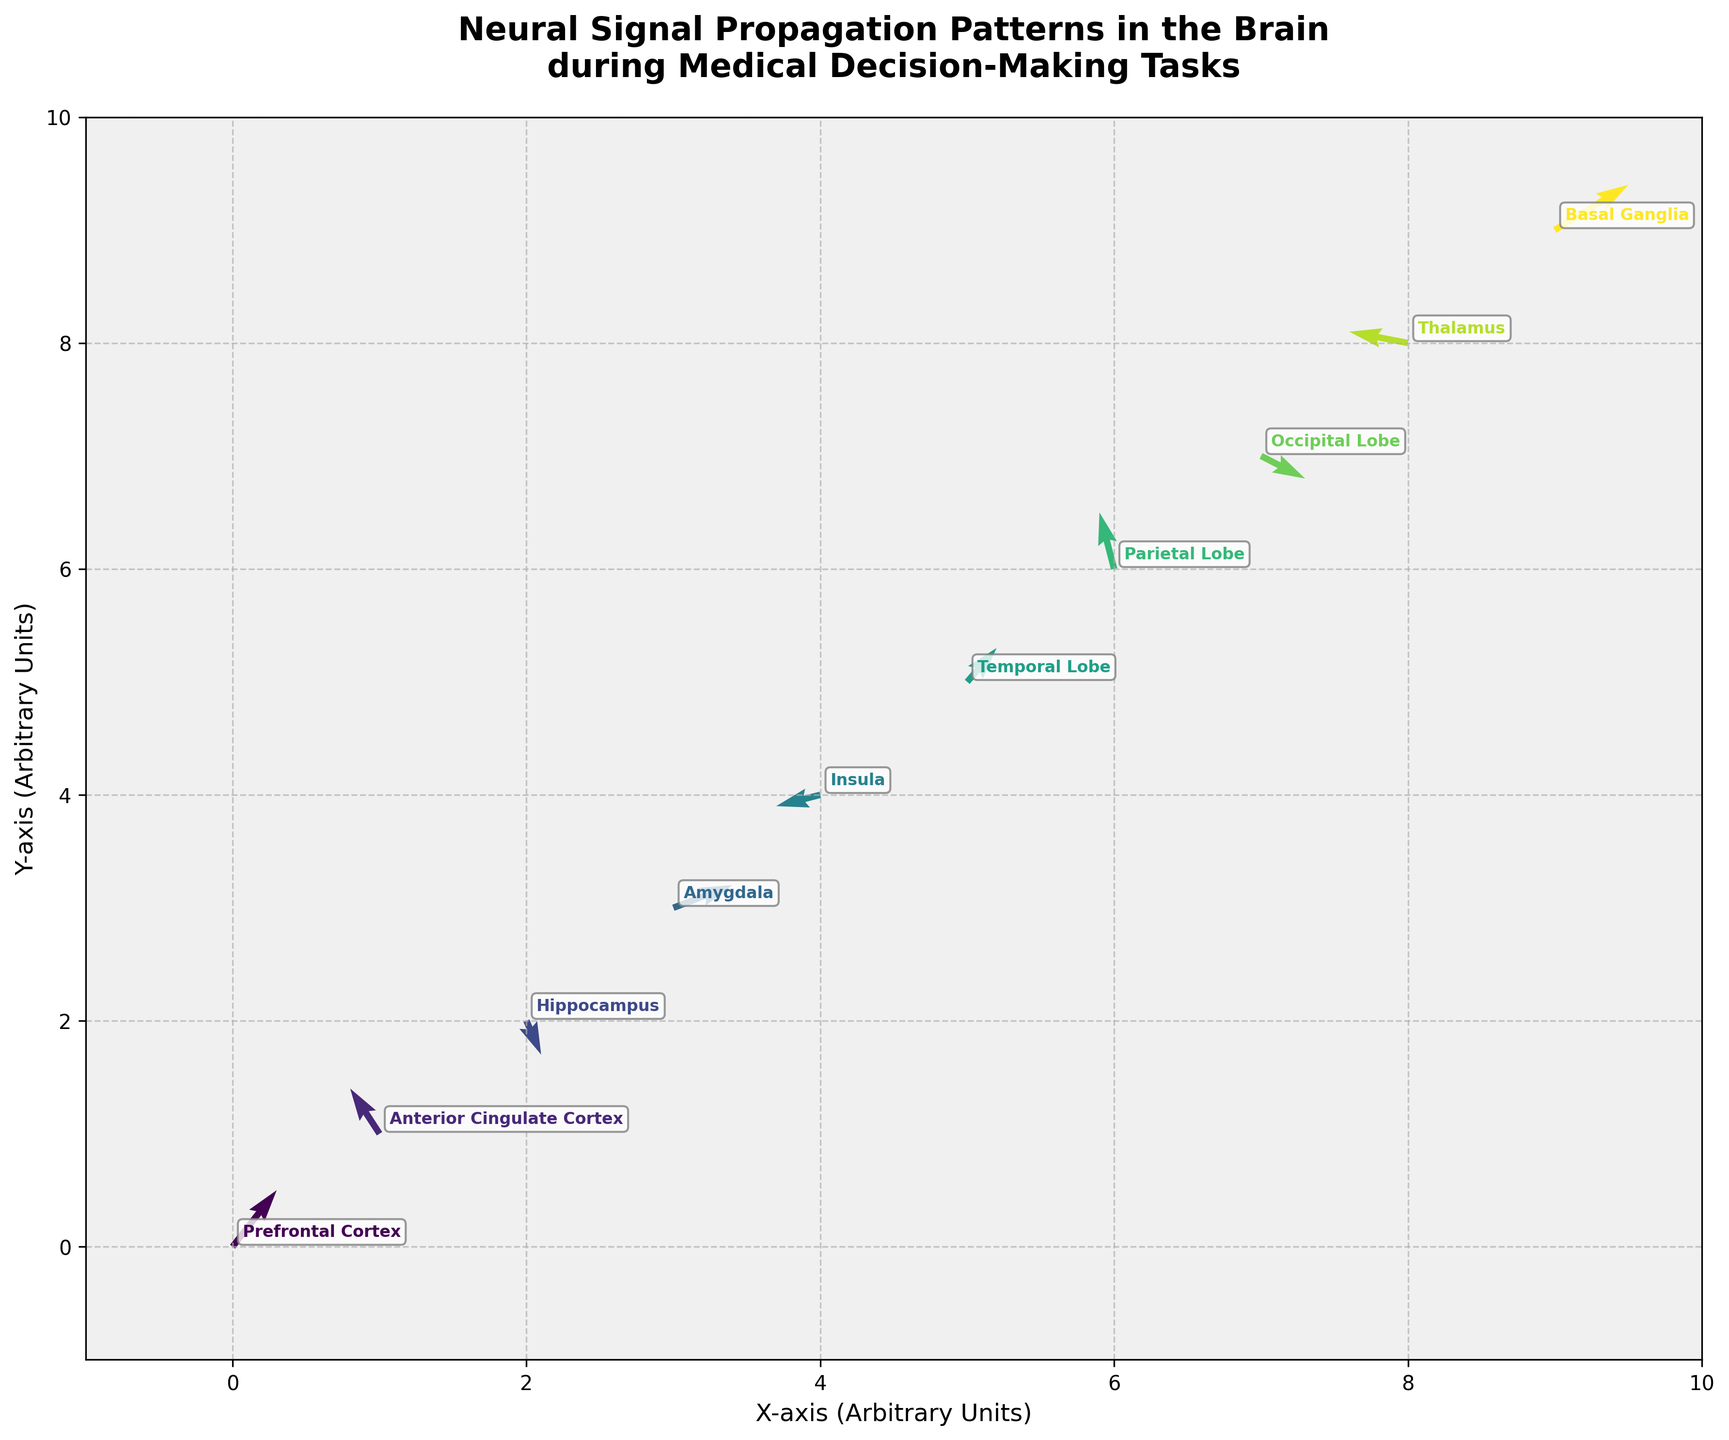What is the title of the figure? The title of the figure is provided near the top of the plot, usually in larger and bold font. It reads 'Neural Signal Propagation Patterns in the Brain during Medical Decision-Making Tasks'.
Answer: Neural Signal Propagation Patterns in the Brain during Medical Decision-Making Tasks How many regions are labeled in the plot? The plot has labels for each of the regions where neural signals are being measured. By counting each label, we find that there are 10 regions labeled.
Answer: 10 Which region shows the largest horizontal (x-axis) signal propagation? To determine this, we look at the magnitude of the horizontal (x-axis) component of the vectors, denoted as \(u\). The Basal Ganglia has the highest u value of 0.5, which is the largest horizontal signal propagation.
Answer: Basal Ganglia Which two regions have opposite directions in signal propagation in the vertical (y-axis) direction? We compare the vertical components (v) of the vectors. The Prefrontal Cortex has a v value of 0.5, indicating upward direction, while the Hippocampus has a v value of -0.3, indicating downward direction. Hence, these two regions have opposite directions in the vertical signal propagation.
Answer: Prefrontal Cortex and Hippocampus What are the coordinates for both the Parietal Lobe and Occipital Lobe in the plot? The coordinates are provided by the x and y columns for each region. Parietal Lobe is at (6, 6) and Occipital Lobe is at (7, 7) as shown on the plot.
Answer: (6, 6) and (7, 7) Which region has the second smallest horizontal (u) signal component? To find the second smallest horizontal component, we list out the u values and find the smallest and second smallest. The second smallest value is -0.3, which belongs to the Insula.
Answer: Insula What is the direction of the signal propagation in the Anterior Cingulate Cortex? By looking at the vector corresponding to the Anterior Cingulate Cortex, with u = -0.2 and v = 0.4, the signal propagation is in the direction of -0.2 units on the x-axis (leftward) and 0.4 units on the y-axis (upward).
Answer: Leftward and Upward What is the sum of the horizontal components of the signal propagation vectors for all regions? Summing the u values for all regions: 0.3 + (-0.2) + 0.1 + 0.4 + (-0.3) + 0.2 + (-0.1) + 0.3 + (-0.4) + 0.5 results in a total of 1.0.
Answer: 1.0 Which region has the vector with the smallest magnitude, and what is the value? The magnitude of vectors is calculated as √(u² + v²). By computing it for each, the smallest magnitude is found to be √((-0.3)² + (-0.1)²) ≈ 0.32 for the Insula.
Answer: Insula, 0.32 Based on the scatter of vectors, which two regions appear to have positively correlated signals in both x and y directions? By examining the directions and magnitudes, Prefrontal Cortex (0.3, 0.5) and Temporal Lobe (0.2, 0.3) have vectors pointing in the positive x and y directions, indicating a positive correlation in signal propagation.
Answer: Prefrontal Cortex and Temporal Lobe 